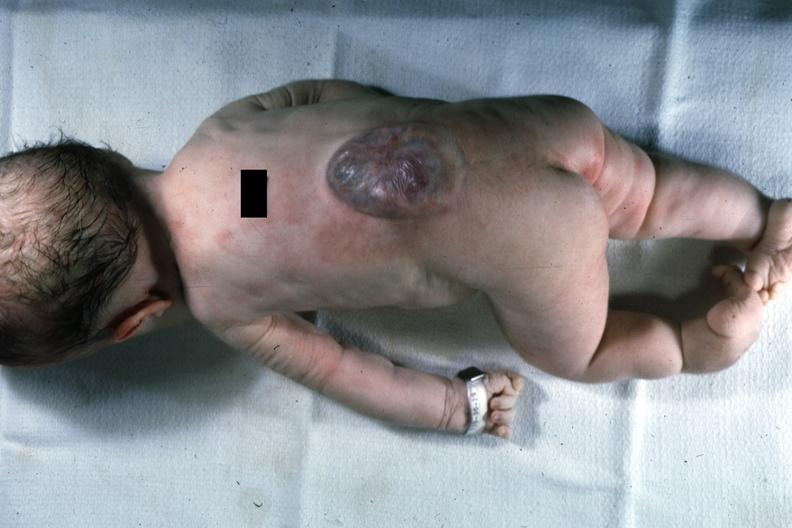what is present?
Answer the question using a single word or phrase. Spina bifida 